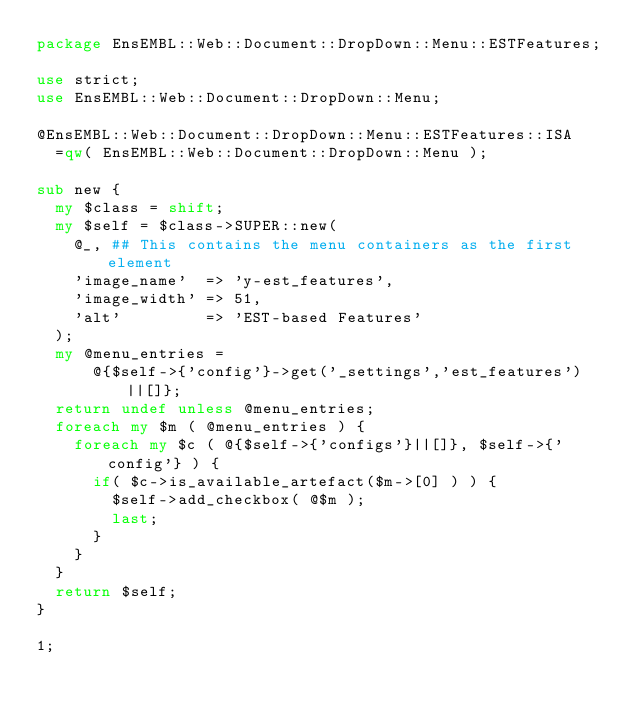Convert code to text. <code><loc_0><loc_0><loc_500><loc_500><_Perl_>package EnsEMBL::Web::Document::DropDown::Menu::ESTFeatures;

use strict;
use EnsEMBL::Web::Document::DropDown::Menu;

@EnsEMBL::Web::Document::DropDown::Menu::ESTFeatures::ISA
  =qw( EnsEMBL::Web::Document::DropDown::Menu );

sub new {
  my $class = shift;
  my $self = $class->SUPER::new(
    @_, ## This contains the menu containers as the first element
    'image_name'  => 'y-est_features',
    'image_width' => 51,
    'alt'         => 'EST-based Features'
  );
  my @menu_entries = 
      @{$self->{'config'}->get('_settings','est_features')||[]};
  return undef unless @menu_entries;
  foreach my $m ( @menu_entries ) {
    foreach my $c ( @{$self->{'configs'}||[]}, $self->{'config'} ) {
      if( $c->is_available_artefact($m->[0] ) ) {
        $self->add_checkbox( @$m );
        last;
      }
    }
  }
  return $self;
}

1;
</code> 